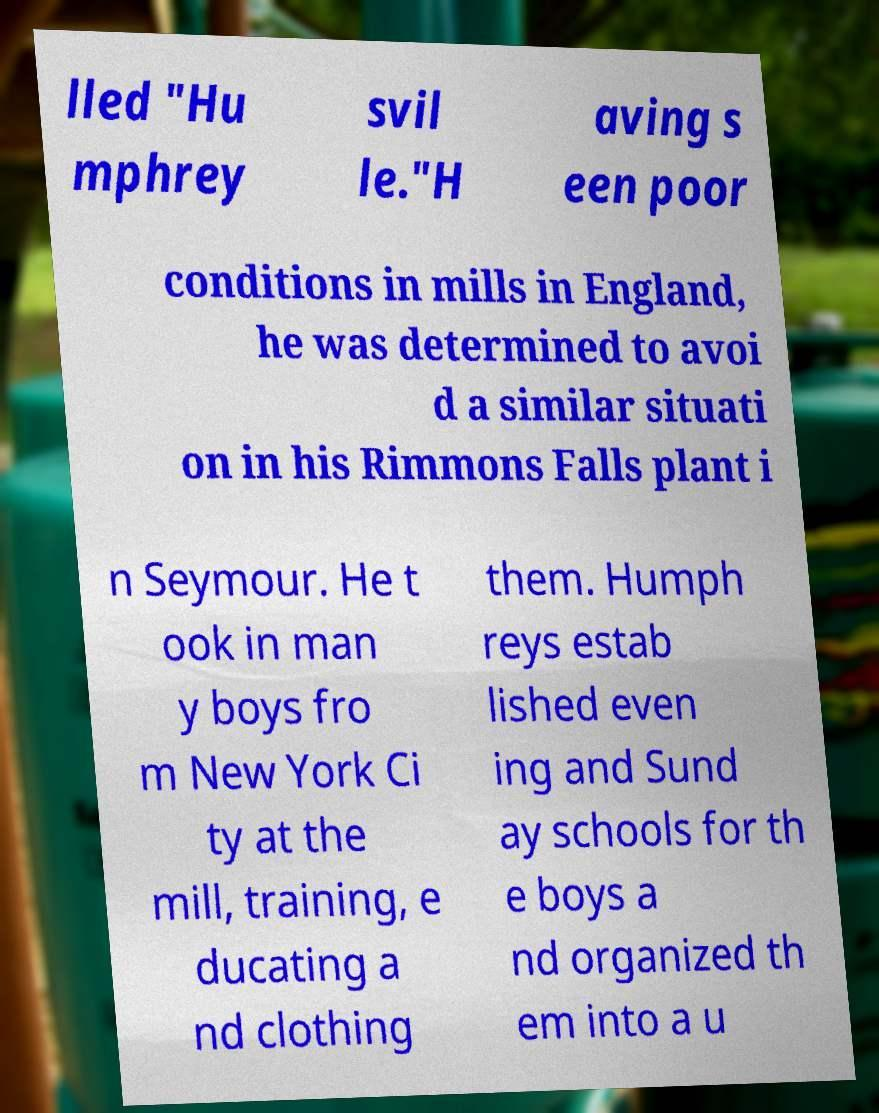I need the written content from this picture converted into text. Can you do that? lled "Hu mphrey svil le."H aving s een poor conditions in mills in England, he was determined to avoi d a similar situati on in his Rimmons Falls plant i n Seymour. He t ook in man y boys fro m New York Ci ty at the mill, training, e ducating a nd clothing them. Humph reys estab lished even ing and Sund ay schools for th e boys a nd organized th em into a u 